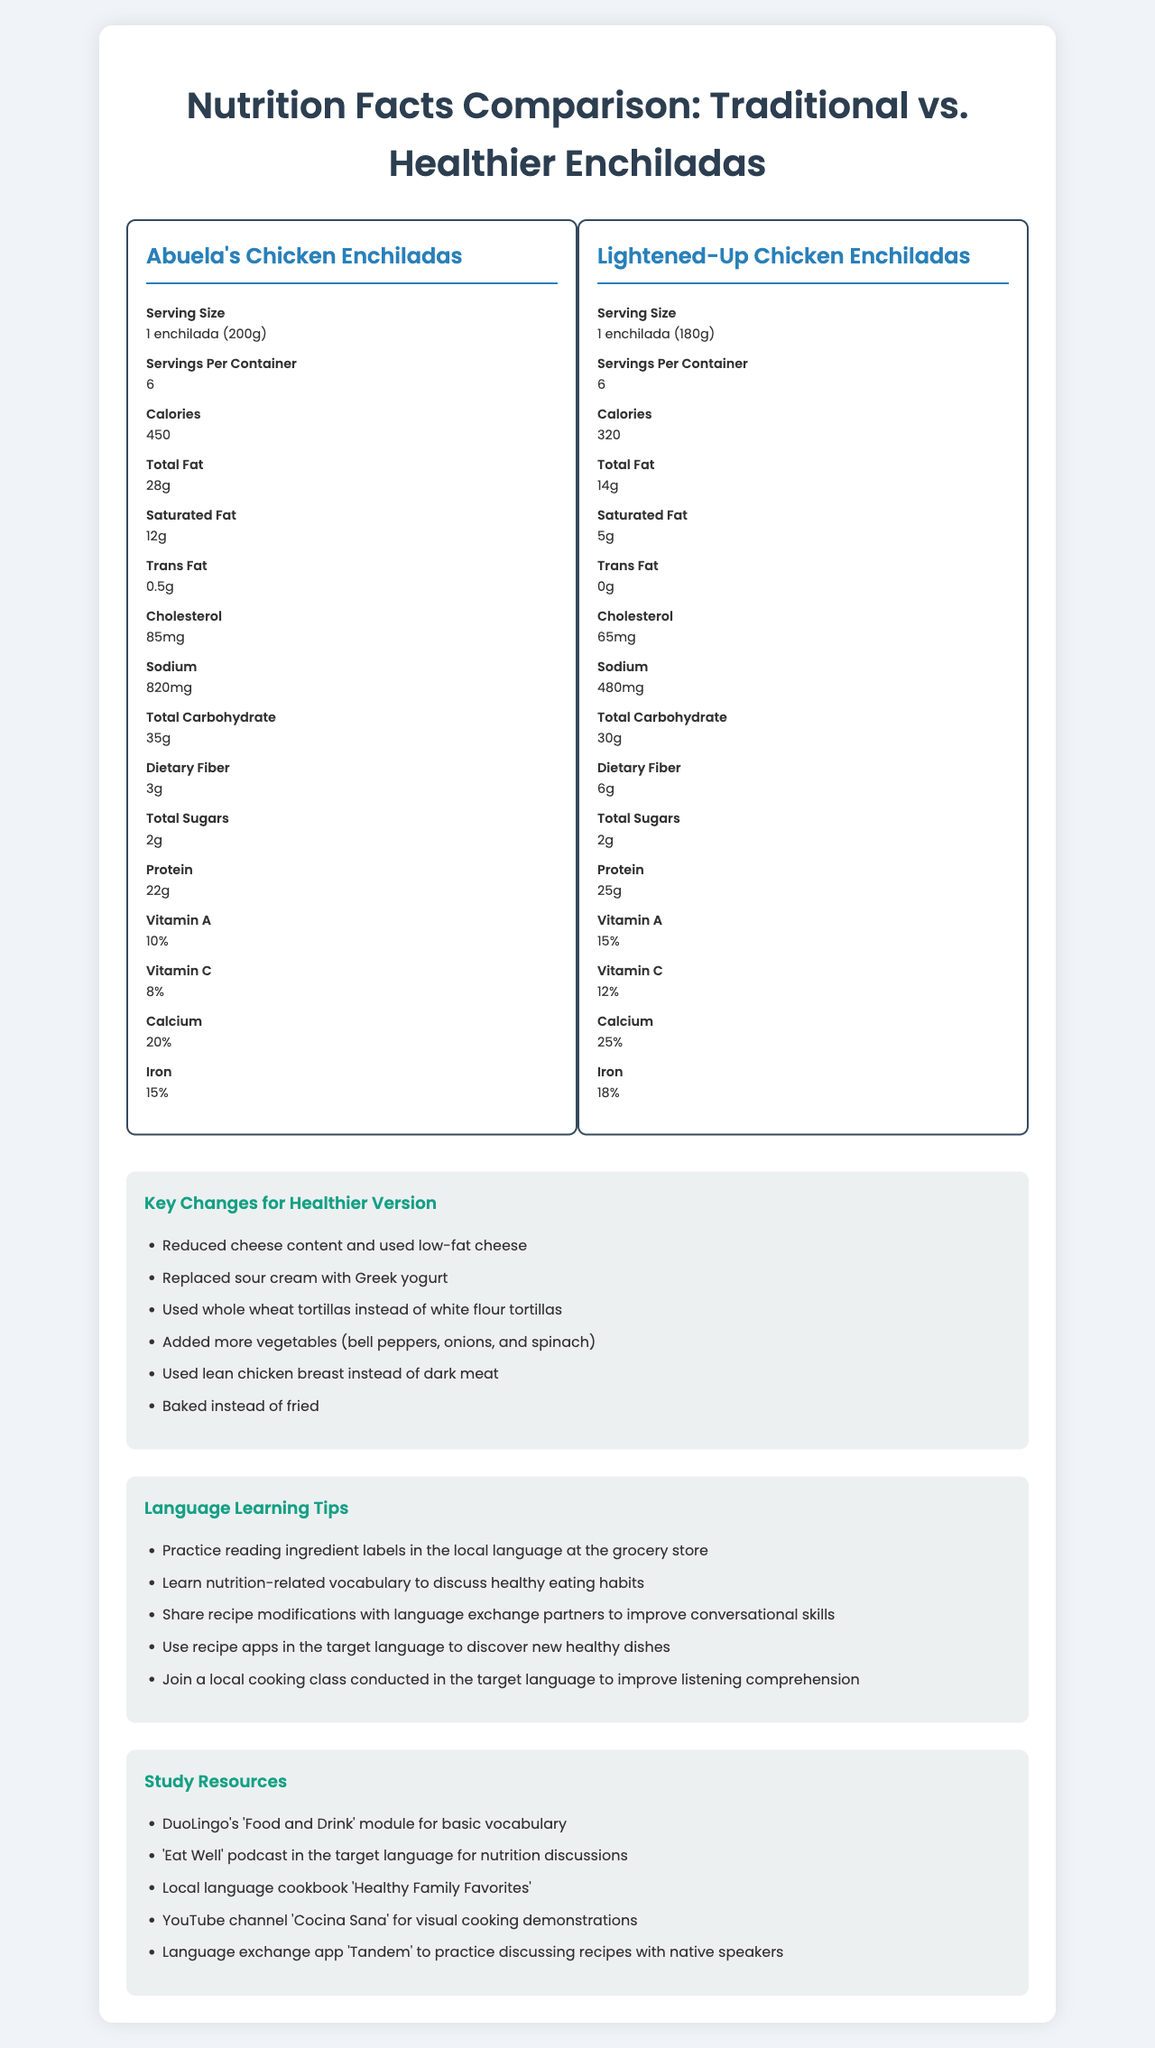what is the serving size for the traditional recipe? The serving size for Abuela's Chicken Enchiladas is listed as 1 enchilada (200g) in the document.
Answer: 1 enchilada (200g) How many servings per container are there in the healthier version? The document specifies that the Lightened-Up Chicken Enchiladas have 6 servings per container.
Answer: 6 servings What is the difference in calories between the traditional and healthier versions? The traditional enchiladas have 450 calories, while the healthier version has 320 calories. The difference is 450 - 320 = 130 calories.
Answer: 130 calories Which enchilada version contains more protein? The healthier version of the enchiladas contains 25g of protein, while the traditional recipe contains 22g.
Answer: Healthier version How much less sodium is in the healthier version compared to the traditional version? The traditional version contains 820mg of sodium, whereas the healthier version contains 480mg. The difference is 820 - 480 = 340mg.
Answer: 340mg Which recipe has more dietary fiber? A. Traditional recipe B. Healthier version The healthier version contains 6g of dietary fiber, whereas the traditional recipe contains 3g.
Answer: B. Healthier version How much more iron is in the healthier version compared to the traditional recipe? A. 1% B. 2% C. 3% D. 4% The traditional recipe has 15% iron, and the healthier version has 18% iron. The difference is 18% - 15% = 3%.
Answer: C. 3% What are the main changes made in the healthier version? A. Reduced cheese content and used low-fat cheese B. Replaced sour cream with Greek yogurt C. Used whole wheat tortillas instead of white flour tortillas D. Added more vegetables (bell peppers, onions, and spinach) E. Used lean chicken breast instead of dark meat F. Baked instead of fried The document lists all these changes as key modifications for the healthier version.
Answer: A, B, C, D, E, F Does the healthier version have more vitamin A compared to the traditional version? The healthier version has 15% vitamin A, while the traditional version has 10%.
Answer: Yes Summarize the key differences between the traditional and healthier enchiladas. The summary is based on the information provided in the nutrition labels and key changes listed in the document.
Answer: The traditional recipe for Abuela's Chicken Enchiladas has higher calories, total fat, saturated fat, cholesterol, and sodium compared to the healthier version. The healthier version, Lightened-Up Chicken Enchiladas, has reduced calories, fats, and sodium. It also includes more dietary fiber, more protein, and slightly higher vitamins and minerals due to changes like using lean chicken, low-fat cheese, Greek yogurt, whole wheat tortillas, and more vegetables. What is the cooking method used in the healthier version? The healthier version of the enchiladas is baked instead of fried, as mentioned in the key changes section.
Answer: Baked Does the document specify the exact amount of each added vegetable in the healthier version? The document mentions the addition of more vegetables such as bell peppers, onions, and spinach but does not specify the exact amount.
Answer: Not enough information What is the percentage of calcium in the healthier version? The nutrition facts of the healthier version list calcium at 25%.
Answer: 25% 